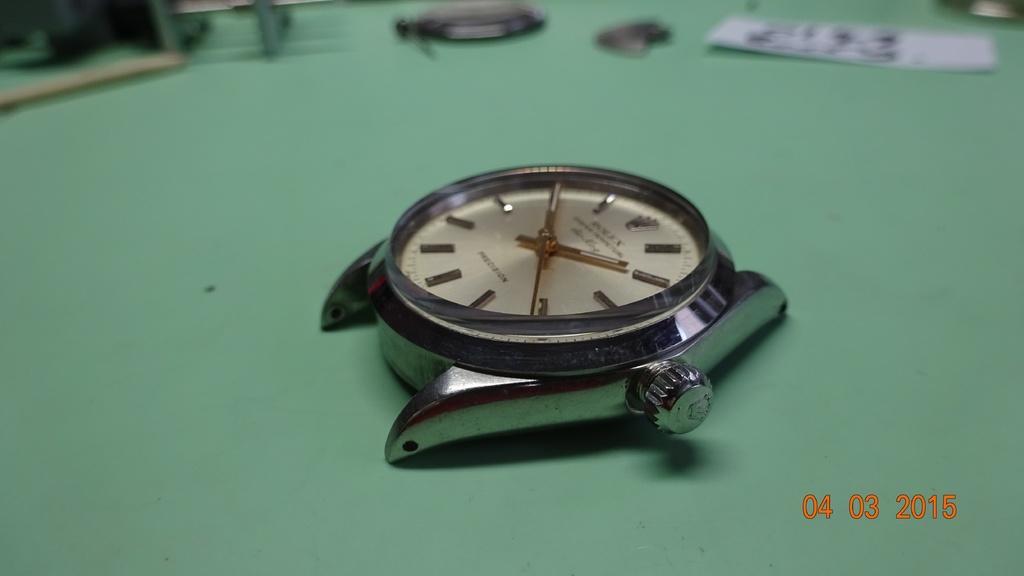Could you give a brief overview of what you see in this image? In this image there is a watch. There is text on the dial. At the top there are a few objects. In the bottom right there are numbers on the image. 